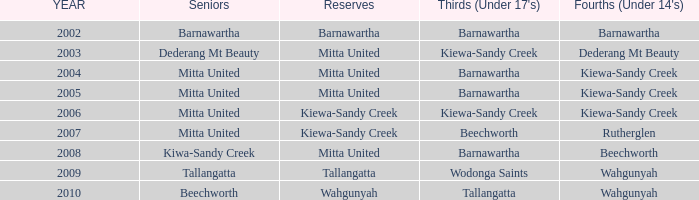Which senior individuals have a year prior to 2007, are in the under 14's category of kiewa-sandy creek, and have a reserve in mitta united? Mitta United, Mitta United. 